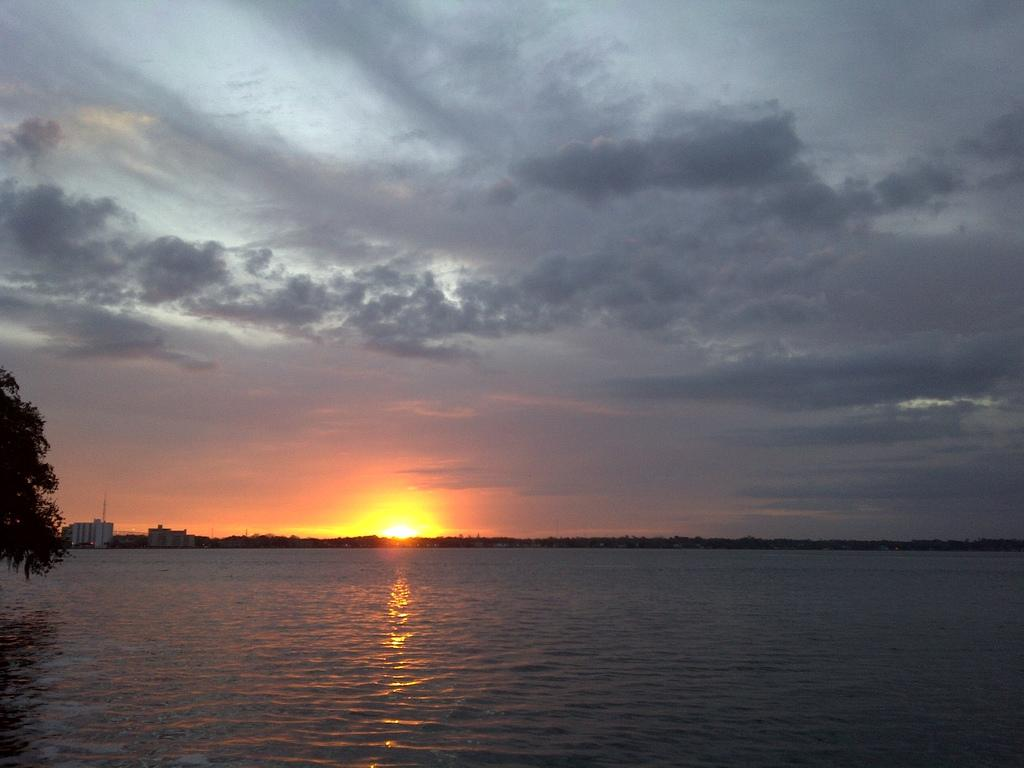What is the main feature of the image? There is a large water body in the image. Are there any natural elements in the image? Yes, there is a tree in the image. What type of man-made structures can be seen in the image? There are buildings in the image. What is the position of the sun in the image? The sun is visible in the image. How would you describe the weather based on the image? The sky appears cloudy in the image. How many snakes are slithering under the tree in the image? There are no snakes present in the image; it only features a tree, buildings, a large water body, the sun, and a cloudy sky. 